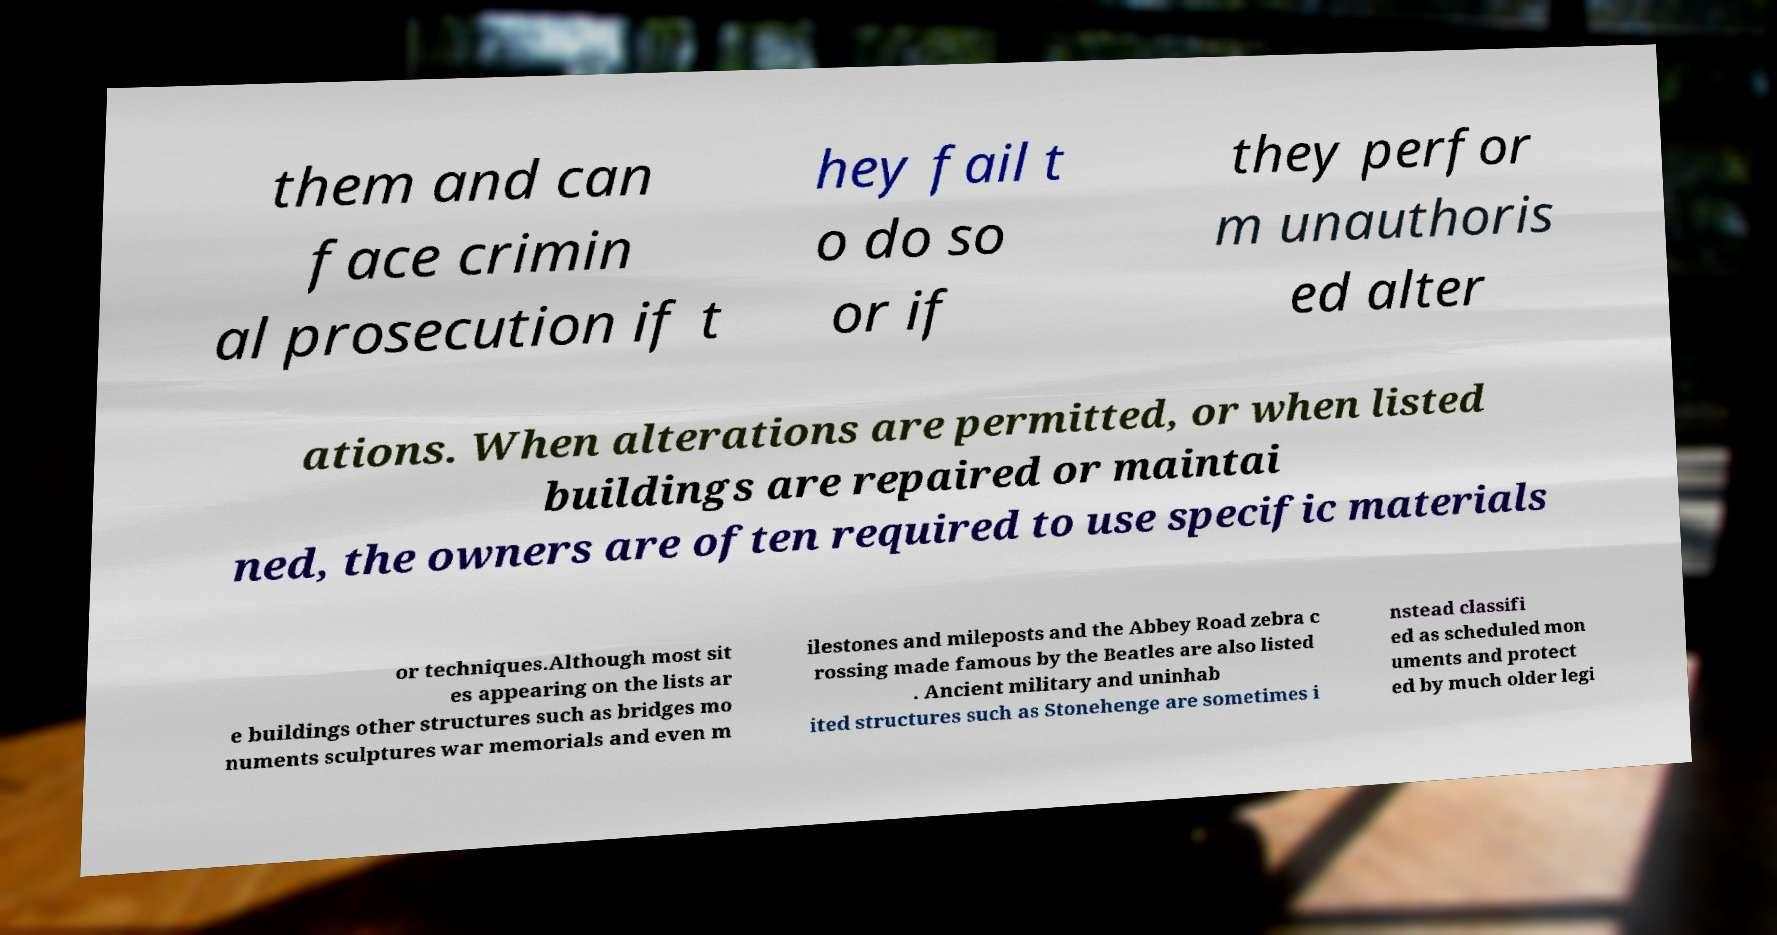Please identify and transcribe the text found in this image. them and can face crimin al prosecution if t hey fail t o do so or if they perfor m unauthoris ed alter ations. When alterations are permitted, or when listed buildings are repaired or maintai ned, the owners are often required to use specific materials or techniques.Although most sit es appearing on the lists ar e buildings other structures such as bridges mo numents sculptures war memorials and even m ilestones and mileposts and the Abbey Road zebra c rossing made famous by the Beatles are also listed . Ancient military and uninhab ited structures such as Stonehenge are sometimes i nstead classifi ed as scheduled mon uments and protect ed by much older legi 